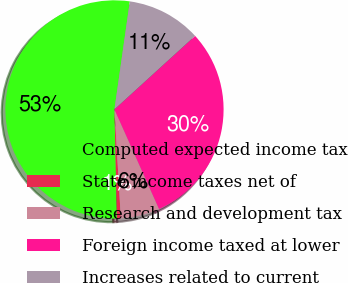<chart> <loc_0><loc_0><loc_500><loc_500><pie_chart><fcel>Computed expected income tax<fcel>State income taxes net of<fcel>Research and development tax<fcel>Foreign income taxed at lower<fcel>Increases related to current<nl><fcel>52.61%<fcel>0.57%<fcel>5.77%<fcel>30.07%<fcel>10.98%<nl></chart> 